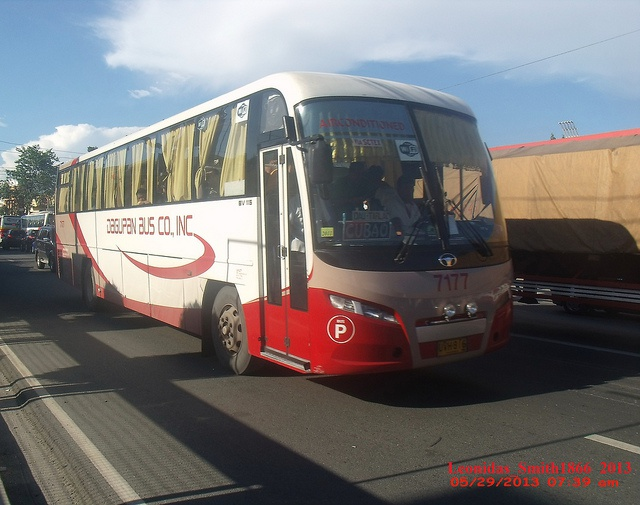Describe the objects in this image and their specific colors. I can see bus in darkgray, gray, black, and ivory tones, people in darkgray, black, and purple tones, people in darkgray, black, and gray tones, car in darkgray, gray, black, and darkblue tones, and bus in darkgray, gray, and white tones in this image. 